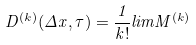<formula> <loc_0><loc_0><loc_500><loc_500>D ^ { ( k ) } ( \Delta x , \tau ) = \frac { 1 } { k ! } l i m M ^ { ( k ) }</formula> 